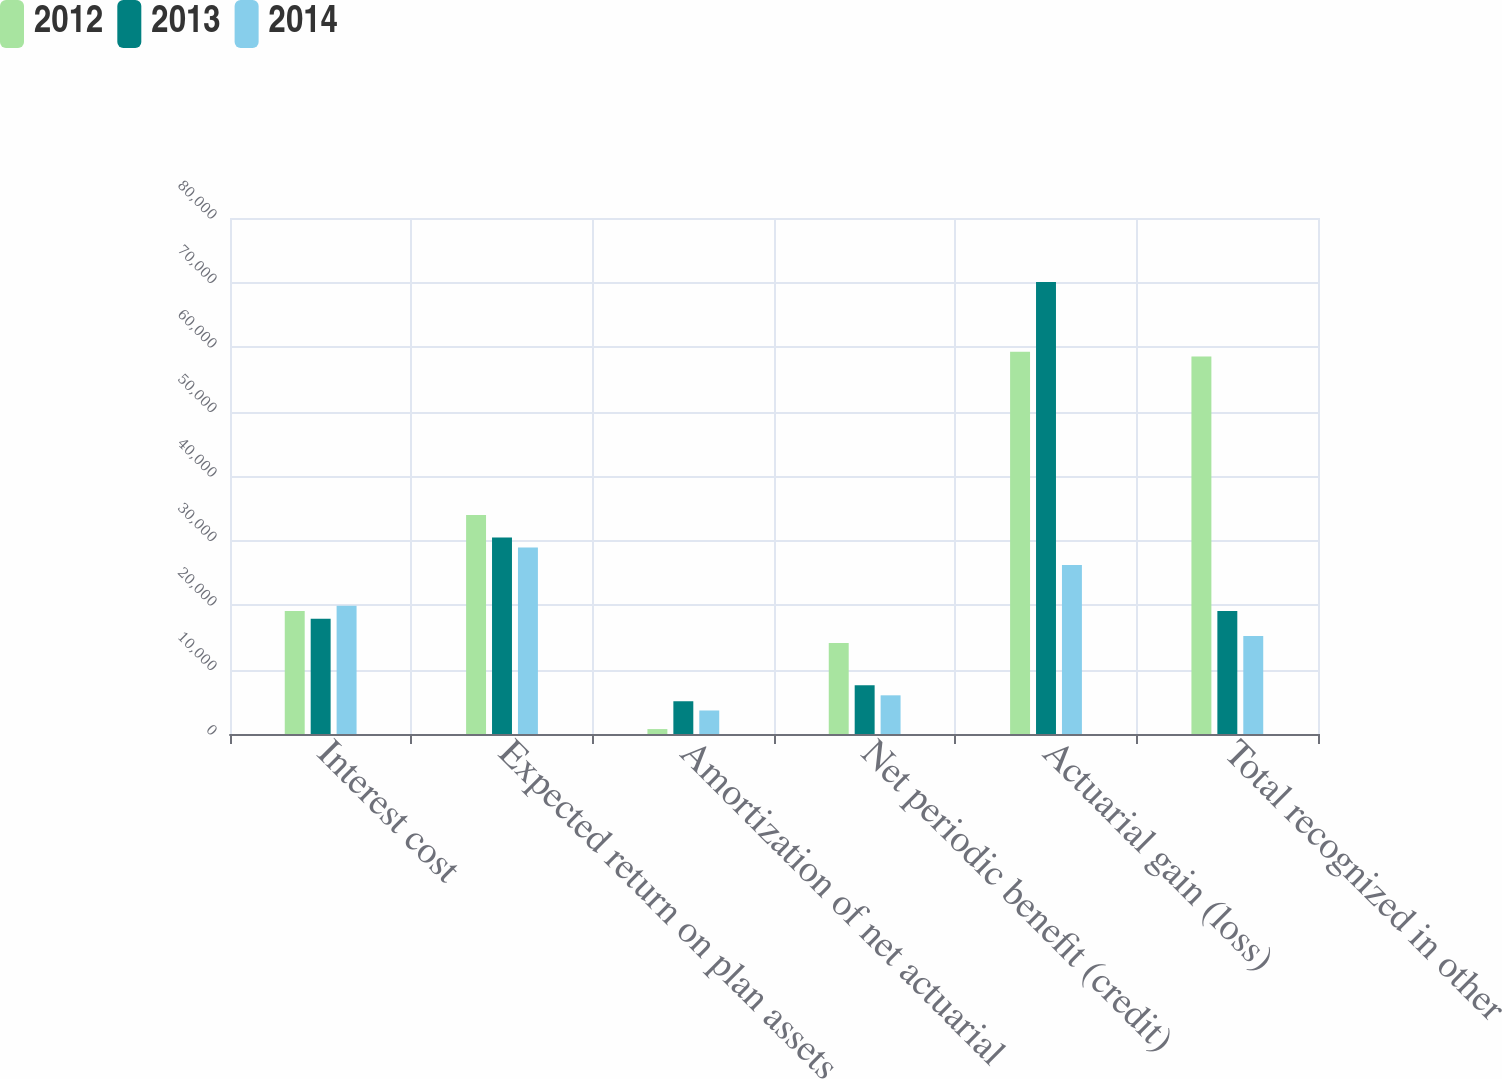Convert chart to OTSL. <chart><loc_0><loc_0><loc_500><loc_500><stacked_bar_chart><ecel><fcel>Interest cost<fcel>Expected return on plan assets<fcel>Amortization of net actuarial<fcel>Net periodic benefit (credit)<fcel>Actuarial gain (loss)<fcel>Total recognized in other<nl><fcel>2012<fcel>19073<fcel>33942<fcel>763<fcel>14106<fcel>59272<fcel>58509<nl><fcel>2013<fcel>17860<fcel>30480<fcel>5078<fcel>7542<fcel>70065<fcel>19073<nl><fcel>2014<fcel>19888<fcel>28899<fcel>3646<fcel>5996<fcel>26184<fcel>15195<nl></chart> 